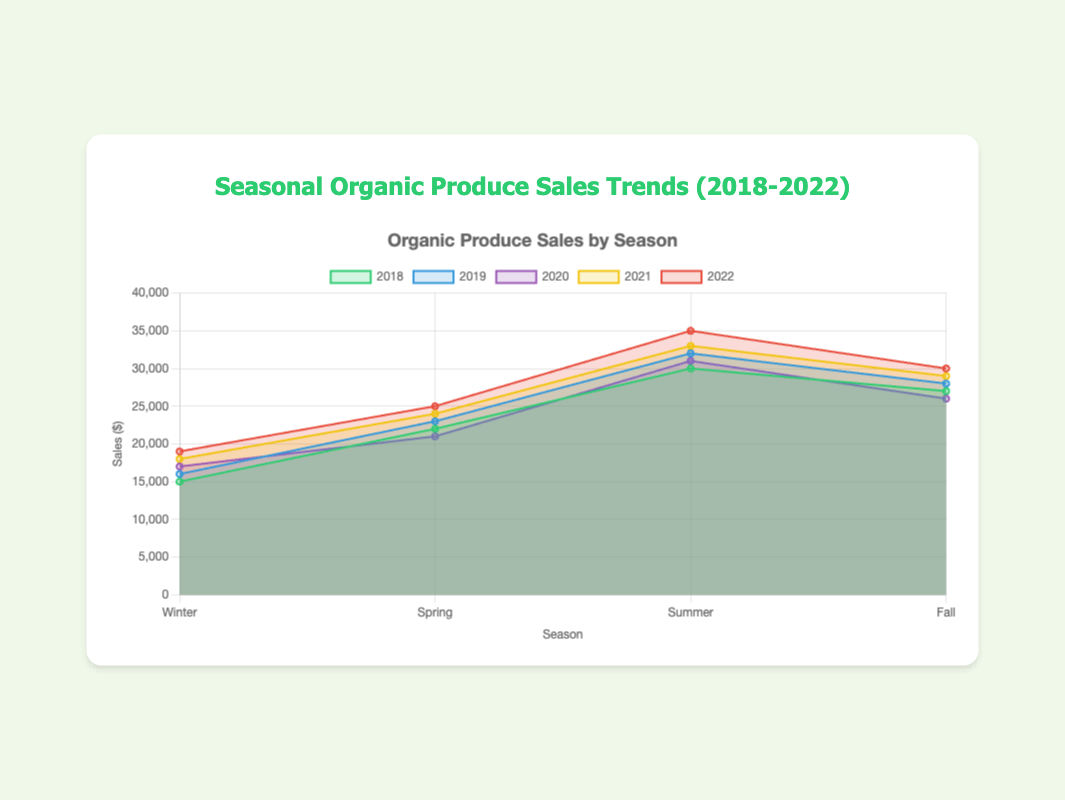Which year had the highest total sales in the summer season? To determine this, observe the summer sales for each year. The sales figures are: 2018: $30,000, 2019: $32,000, 2020: $31,000, 2021: $33,000, 2022: $35,000. The highest value is $35,000 in 2022.
Answer: 2022 What is the total sales difference between Winter and Fall for the year 2020? Look at the sales for Winter ($17,000) and Fall ($26,000) in 2020. Calculate the difference, which is $26,000 - $17,000 = $9,000.
Answer: $9,000 Which season consistently had increasing sales from 2018 to 2022? Check the sales for each season year by year. Summer's sales figures are continually increasing: 2018: $30,000, 2019: $32,000, 2020: $31,000, 2021: $33,000, 2022: $35,000.
Answer: Summer What was the average Spring sales over the five years? Sum the Spring sales from 2018 to 2022 and divide by 5: ($22,000 + $23,000 + $21,000 + $24,000 + $25,000) / 5. This results in ($115,000 / 5 = $23,000).
Answer: $23,000 In which year did the Winter sales surpass $18,000? Look at Winter sales from each year. The sales surpass $18,000 only in 2021 ($18,000) and 2022 ($19,000).
Answer: 2021, 2022 Which season had the lowest sales in 2019? Observe the sales for each season in 2019: Winter ($16,000), Spring ($23,000), Summer ($32,000), Fall ($28,000). The lowest is Winter with $16,000.
Answer: Winter How does Fall sales in 2020 compare to Summer sales in 2018? Compare the sales values: Fall 2020 is $26,000, Summer 2018 is $30,000. Summer 2018 has higher sales.
Answer: Summer 2018 What’s the combined sales for Summer and Fall in 2022? Add the Summer and Fall sales for 2022: $35,000 (Summer) + $30,000 (Fall) = $65,000.
Answer: $65,000 When did the Spring season first exceed $24,000 in sales? Review the Spring sales from each year. Spring 2022 reached $25,000, which is the first instance exceeding $24,000.
Answer: 2022 